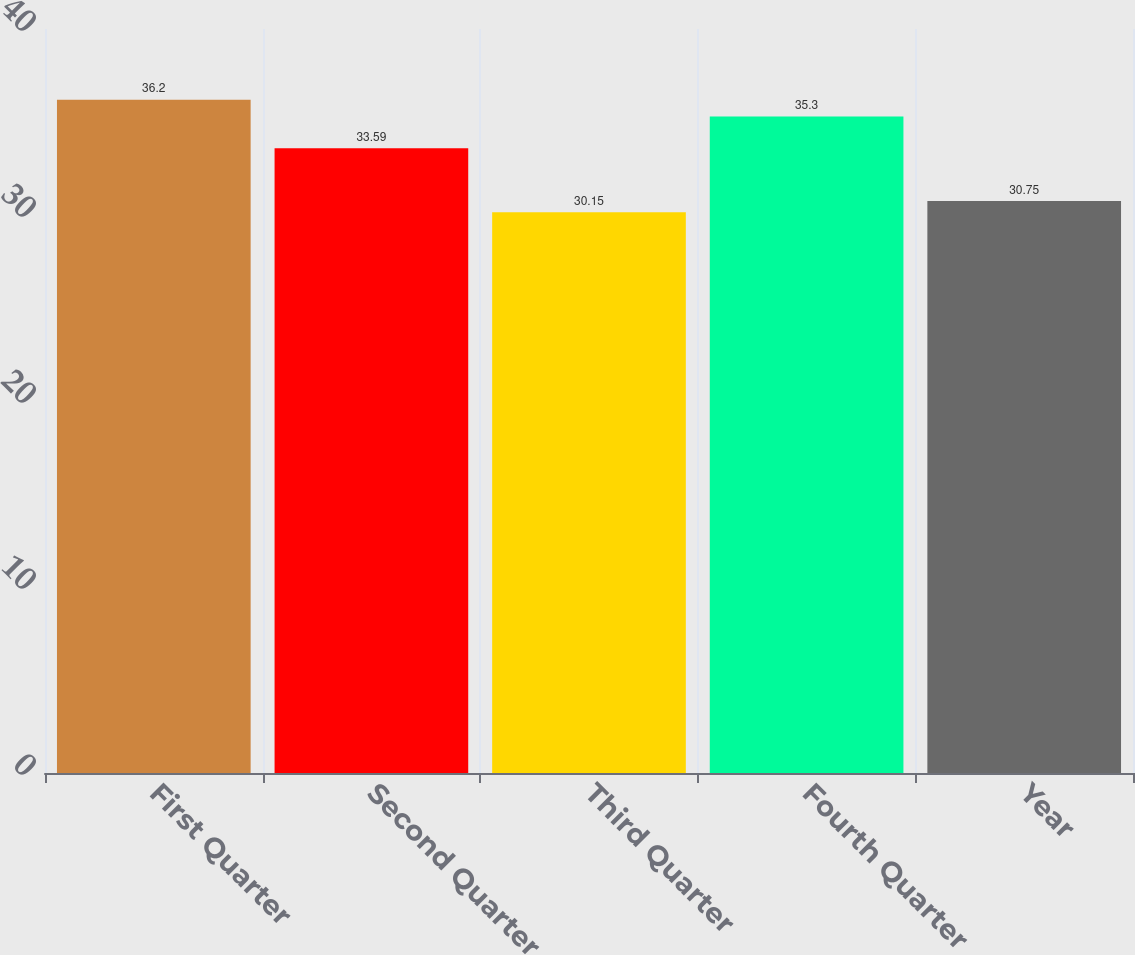Convert chart to OTSL. <chart><loc_0><loc_0><loc_500><loc_500><bar_chart><fcel>First Quarter<fcel>Second Quarter<fcel>Third Quarter<fcel>Fourth Quarter<fcel>Year<nl><fcel>36.2<fcel>33.59<fcel>30.15<fcel>35.3<fcel>30.75<nl></chart> 